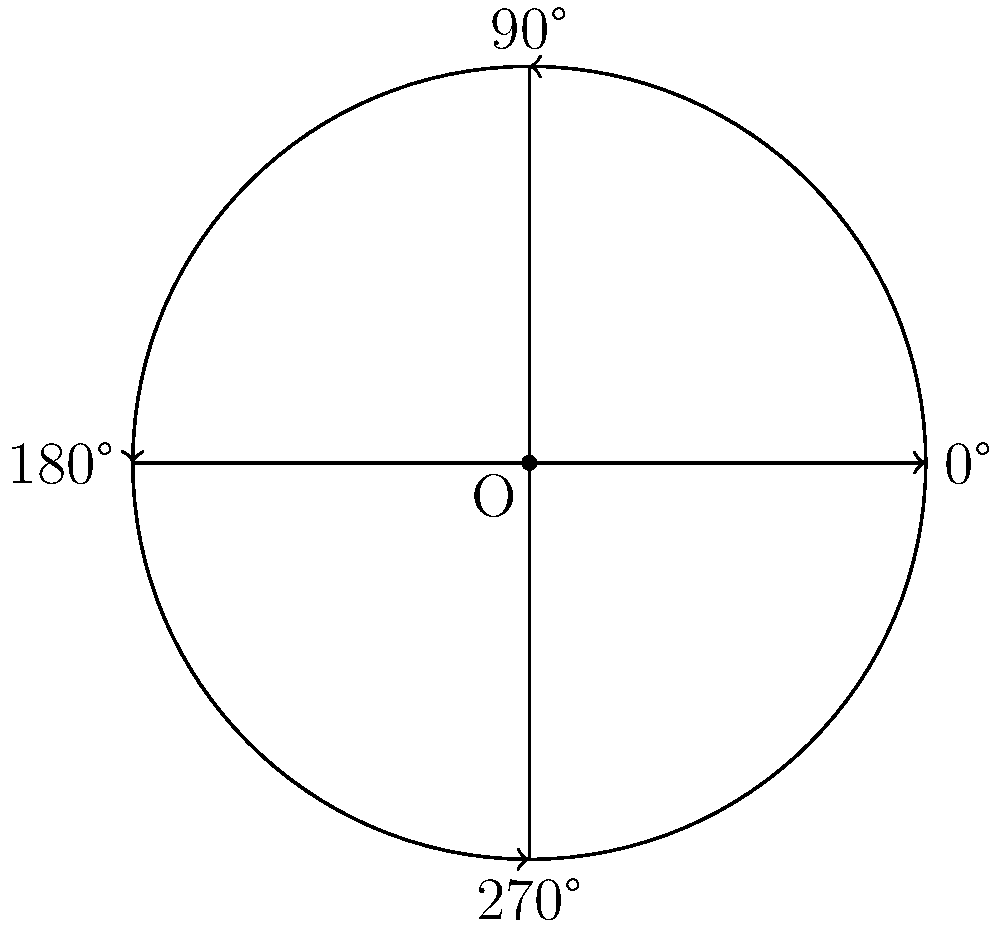In a hospice care setting, you use a circular medical chart symbol to represent different patient conditions. The symbol rotates around its center point O. If the initial position (0°) indicates "Stable", a 90° clockwise rotation represents "Improving", a 180° rotation represents "Declining", and a 270° rotation represents "Critical", what degree of rotation would you use to indicate a patient's condition has changed from "Improving" to "Critical"? To solve this problem, let's follow these steps:

1. Identify the initial position:
   - "Improving" is at 90° clockwise rotation from "Stable"

2. Identify the final position:
   - "Critical" is at 270° clockwise rotation from "Stable"

3. Calculate the rotation needed:
   - We need to rotate from 90° to 270°
   - The rotation angle is the difference between these two positions
   - $270° - 90° = 180°$

4. Verify the direction:
   - The rotation from "Improving" to "Critical" is clockwise, which matches our calculation

Therefore, a 180° clockwise rotation is needed to move from "Improving" to "Critical" on the medical chart symbol.
Answer: 180° 